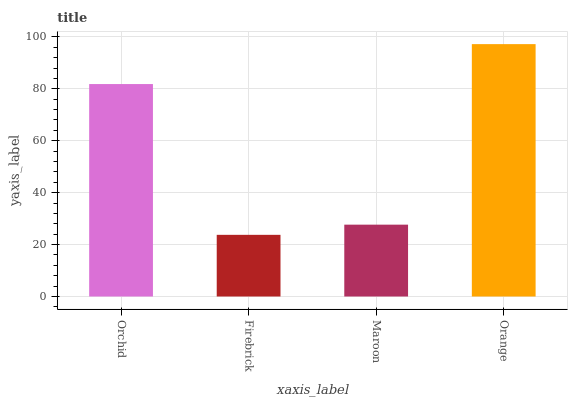Is Firebrick the minimum?
Answer yes or no. Yes. Is Orange the maximum?
Answer yes or no. Yes. Is Maroon the minimum?
Answer yes or no. No. Is Maroon the maximum?
Answer yes or no. No. Is Maroon greater than Firebrick?
Answer yes or no. Yes. Is Firebrick less than Maroon?
Answer yes or no. Yes. Is Firebrick greater than Maroon?
Answer yes or no. No. Is Maroon less than Firebrick?
Answer yes or no. No. Is Orchid the high median?
Answer yes or no. Yes. Is Maroon the low median?
Answer yes or no. Yes. Is Maroon the high median?
Answer yes or no. No. Is Orchid the low median?
Answer yes or no. No. 